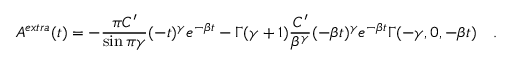<formula> <loc_0><loc_0><loc_500><loc_500>A ^ { e x t r a } ( t ) = - \frac { \pi C ^ { \prime } } { \sin \pi \gamma } ( - t ) ^ { \gamma } e ^ { - \beta t } - \Gamma ( \gamma + 1 ) \frac { C ^ { \prime } } { \beta ^ { \gamma } } ( - \beta t ) ^ { \gamma } e ^ { - \beta t } \Gamma ( - \gamma , 0 , - \beta t ) \quad .</formula> 